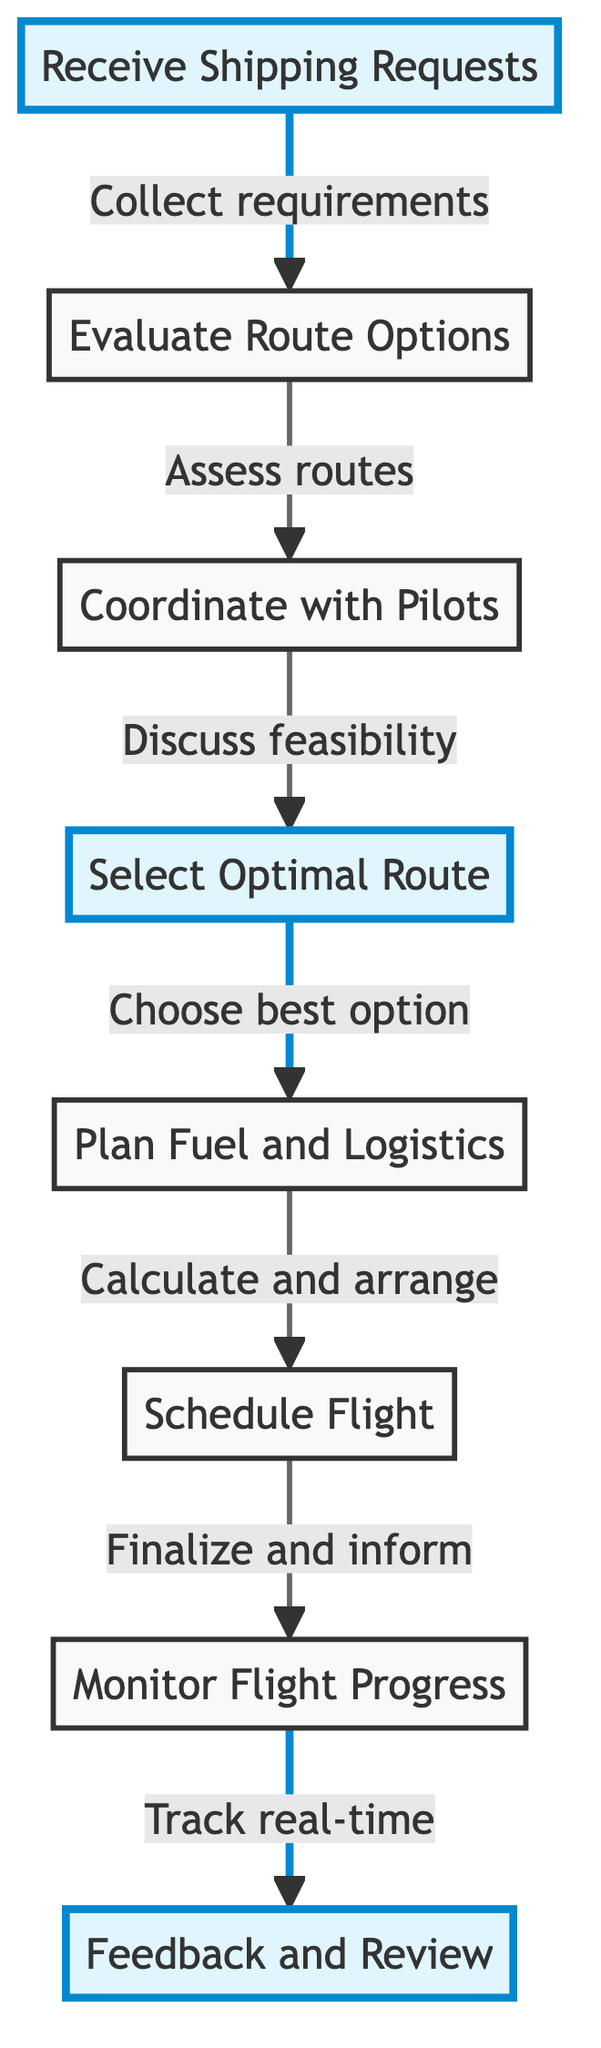What is the first step in the diagram? The first step in the flow chart is 'Receive Shipping Requests', as indicated by the starting node.
Answer: Receive Shipping Requests How many nodes are present in the diagram? The diagram contains eight nodes, each representing a distinct step in the logistics process.
Answer: 8 Which node follows 'Evaluate Route Options'? 'Coordinate with Pilots' follows 'Evaluate Route Options', as shown by the directional connection from one step to the next in the flow.
Answer: Coordinate with Pilots What is the final step of the process? The final step in the flow chart is 'Feedback and Review', as it is the last node with no subsequent connections.
Answer: Feedback and Review What does 'Select Optimal Route' lead to? 'Select Optimal Route' leads to 'Plan Fuel and Logistics', which indicates the progression to planning support elements for the selected route.
Answer: Plan Fuel and Logistics Why is 'Feedback and Review' highlighted? 'Feedback and Review' is highlighted because it represents critical evaluation, emphasizing the importance of gathering insights for future improvements after the flight.
Answer: Critical evaluation How many decision points involve pilot coordination? There are two decision points that involve pilot coordination: 'Coordinate with Pilots' and 'Select Optimal Route', where pilot feedback is integral.
Answer: 2 Which step involves scheduling the flight? The step that involves scheduling the flight is 'Schedule Flight', as indicated in the flow chart sequence after logistical planning.
Answer: Schedule Flight 